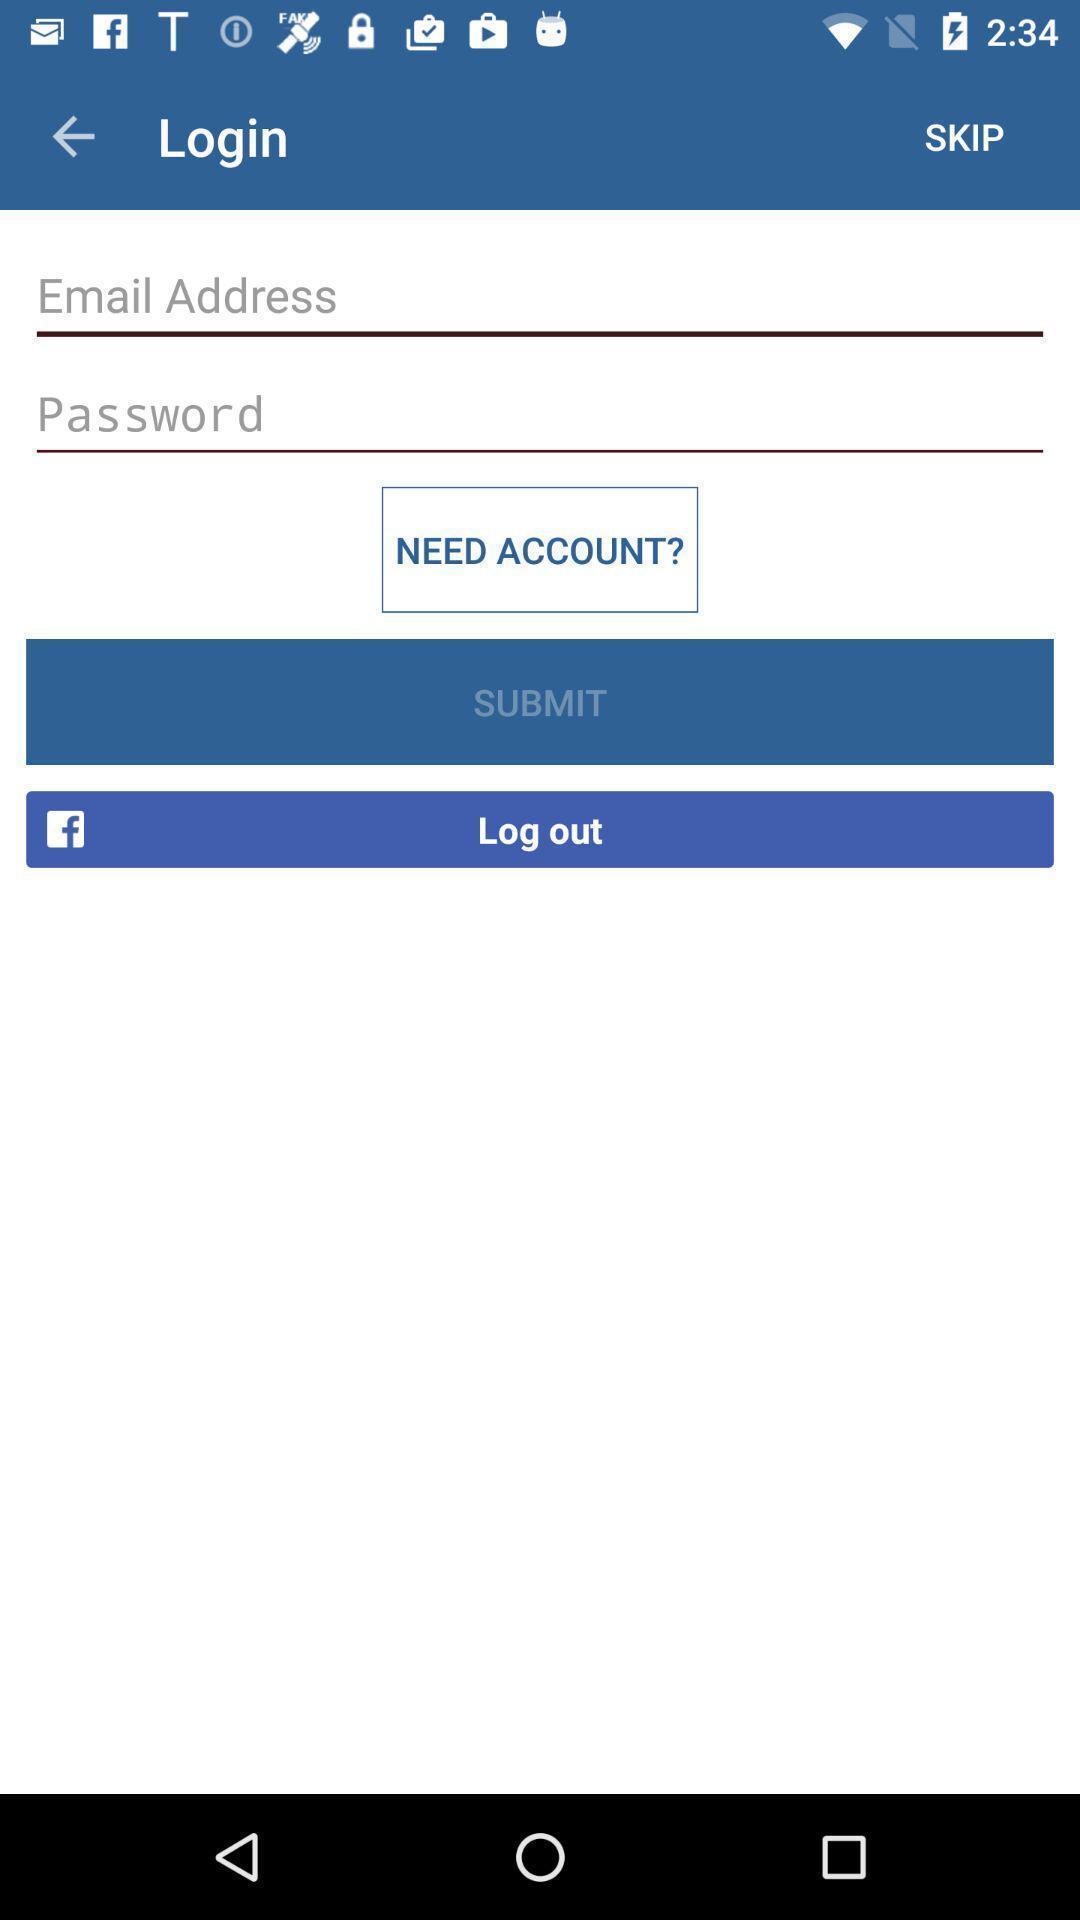Tell me about the visual elements in this screen capture. Login page shows email and password in an service application. 